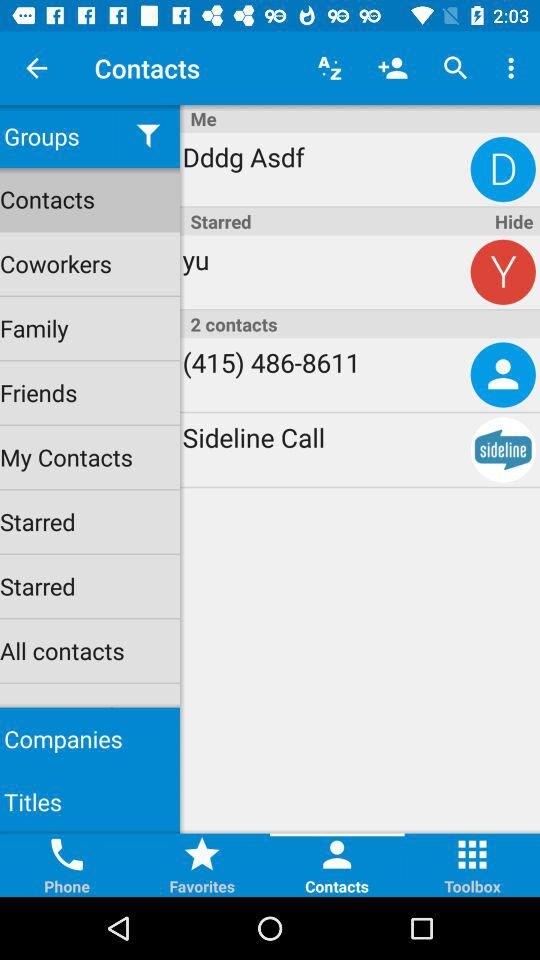What phone number is shown on the screen? The phone number is (415) 486-8611. 